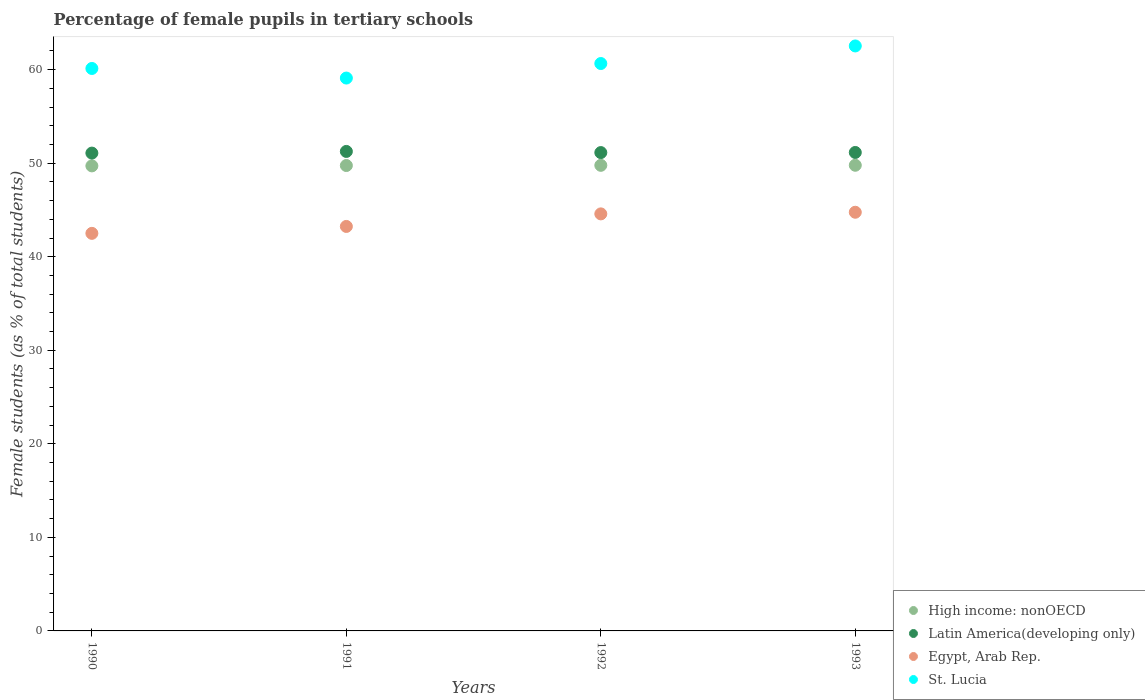What is the percentage of female pupils in tertiary schools in St. Lucia in 1992?
Ensure brevity in your answer.  60.65. Across all years, what is the maximum percentage of female pupils in tertiary schools in Latin America(developing only)?
Your answer should be very brief. 51.26. Across all years, what is the minimum percentage of female pupils in tertiary schools in St. Lucia?
Your answer should be very brief. 59.1. In which year was the percentage of female pupils in tertiary schools in St. Lucia maximum?
Your answer should be compact. 1993. What is the total percentage of female pupils in tertiary schools in Latin America(developing only) in the graph?
Offer a terse response. 204.62. What is the difference between the percentage of female pupils in tertiary schools in Latin America(developing only) in 1991 and that in 1992?
Provide a succinct answer. 0.12. What is the difference between the percentage of female pupils in tertiary schools in Egypt, Arab Rep. in 1992 and the percentage of female pupils in tertiary schools in St. Lucia in 1990?
Your response must be concise. -15.54. What is the average percentage of female pupils in tertiary schools in High income: nonOECD per year?
Offer a terse response. 49.75. In the year 1993, what is the difference between the percentage of female pupils in tertiary schools in Egypt, Arab Rep. and percentage of female pupils in tertiary schools in Latin America(developing only)?
Ensure brevity in your answer.  -6.39. What is the ratio of the percentage of female pupils in tertiary schools in High income: nonOECD in 1990 to that in 1993?
Your answer should be compact. 1. What is the difference between the highest and the second highest percentage of female pupils in tertiary schools in Latin America(developing only)?
Give a very brief answer. 0.11. What is the difference between the highest and the lowest percentage of female pupils in tertiary schools in Egypt, Arab Rep.?
Ensure brevity in your answer.  2.26. Is the sum of the percentage of female pupils in tertiary schools in Egypt, Arab Rep. in 1990 and 1993 greater than the maximum percentage of female pupils in tertiary schools in St. Lucia across all years?
Ensure brevity in your answer.  Yes. Is it the case that in every year, the sum of the percentage of female pupils in tertiary schools in Egypt, Arab Rep. and percentage of female pupils in tertiary schools in High income: nonOECD  is greater than the sum of percentage of female pupils in tertiary schools in St. Lucia and percentage of female pupils in tertiary schools in Latin America(developing only)?
Give a very brief answer. No. Does the percentage of female pupils in tertiary schools in Latin America(developing only) monotonically increase over the years?
Ensure brevity in your answer.  No. Is the percentage of female pupils in tertiary schools in High income: nonOECD strictly greater than the percentage of female pupils in tertiary schools in St. Lucia over the years?
Give a very brief answer. No. How many dotlines are there?
Offer a very short reply. 4. Does the graph contain grids?
Keep it short and to the point. No. How are the legend labels stacked?
Offer a terse response. Vertical. What is the title of the graph?
Offer a terse response. Percentage of female pupils in tertiary schools. What is the label or title of the X-axis?
Offer a terse response. Years. What is the label or title of the Y-axis?
Keep it short and to the point. Female students (as % of total students). What is the Female students (as % of total students) of High income: nonOECD in 1990?
Give a very brief answer. 49.71. What is the Female students (as % of total students) in Latin America(developing only) in 1990?
Provide a succinct answer. 51.08. What is the Female students (as % of total students) of Egypt, Arab Rep. in 1990?
Your answer should be very brief. 42.5. What is the Female students (as % of total students) in St. Lucia in 1990?
Your response must be concise. 60.13. What is the Female students (as % of total students) of High income: nonOECD in 1991?
Keep it short and to the point. 49.75. What is the Female students (as % of total students) in Latin America(developing only) in 1991?
Make the answer very short. 51.26. What is the Female students (as % of total students) in Egypt, Arab Rep. in 1991?
Offer a very short reply. 43.24. What is the Female students (as % of total students) of St. Lucia in 1991?
Make the answer very short. 59.1. What is the Female students (as % of total students) of High income: nonOECD in 1992?
Offer a terse response. 49.77. What is the Female students (as % of total students) of Latin America(developing only) in 1992?
Keep it short and to the point. 51.13. What is the Female students (as % of total students) in Egypt, Arab Rep. in 1992?
Your response must be concise. 44.58. What is the Female students (as % of total students) of St. Lucia in 1992?
Your answer should be compact. 60.65. What is the Female students (as % of total students) in High income: nonOECD in 1993?
Provide a succinct answer. 49.78. What is the Female students (as % of total students) in Latin America(developing only) in 1993?
Offer a terse response. 51.15. What is the Female students (as % of total students) of Egypt, Arab Rep. in 1993?
Make the answer very short. 44.76. What is the Female students (as % of total students) in St. Lucia in 1993?
Provide a succinct answer. 62.53. Across all years, what is the maximum Female students (as % of total students) of High income: nonOECD?
Your answer should be compact. 49.78. Across all years, what is the maximum Female students (as % of total students) of Latin America(developing only)?
Your answer should be very brief. 51.26. Across all years, what is the maximum Female students (as % of total students) of Egypt, Arab Rep.?
Provide a succinct answer. 44.76. Across all years, what is the maximum Female students (as % of total students) of St. Lucia?
Your answer should be very brief. 62.53. Across all years, what is the minimum Female students (as % of total students) of High income: nonOECD?
Ensure brevity in your answer.  49.71. Across all years, what is the minimum Female students (as % of total students) in Latin America(developing only)?
Make the answer very short. 51.08. Across all years, what is the minimum Female students (as % of total students) in Egypt, Arab Rep.?
Provide a short and direct response. 42.5. Across all years, what is the minimum Female students (as % of total students) of St. Lucia?
Your answer should be very brief. 59.1. What is the total Female students (as % of total students) of High income: nonOECD in the graph?
Provide a short and direct response. 199.01. What is the total Female students (as % of total students) of Latin America(developing only) in the graph?
Keep it short and to the point. 204.62. What is the total Female students (as % of total students) of Egypt, Arab Rep. in the graph?
Keep it short and to the point. 175.08. What is the total Female students (as % of total students) in St. Lucia in the graph?
Your response must be concise. 242.41. What is the difference between the Female students (as % of total students) in High income: nonOECD in 1990 and that in 1991?
Offer a terse response. -0.04. What is the difference between the Female students (as % of total students) in Latin America(developing only) in 1990 and that in 1991?
Provide a succinct answer. -0.18. What is the difference between the Female students (as % of total students) of Egypt, Arab Rep. in 1990 and that in 1991?
Provide a succinct answer. -0.74. What is the difference between the Female students (as % of total students) in St. Lucia in 1990 and that in 1991?
Your response must be concise. 1.02. What is the difference between the Female students (as % of total students) of High income: nonOECD in 1990 and that in 1992?
Keep it short and to the point. -0.06. What is the difference between the Female students (as % of total students) in Latin America(developing only) in 1990 and that in 1992?
Provide a succinct answer. -0.06. What is the difference between the Female students (as % of total students) in Egypt, Arab Rep. in 1990 and that in 1992?
Your answer should be very brief. -2.08. What is the difference between the Female students (as % of total students) in St. Lucia in 1990 and that in 1992?
Give a very brief answer. -0.53. What is the difference between the Female students (as % of total students) in High income: nonOECD in 1990 and that in 1993?
Ensure brevity in your answer.  -0.07. What is the difference between the Female students (as % of total students) of Latin America(developing only) in 1990 and that in 1993?
Offer a terse response. -0.07. What is the difference between the Female students (as % of total students) in Egypt, Arab Rep. in 1990 and that in 1993?
Your answer should be compact. -2.26. What is the difference between the Female students (as % of total students) in St. Lucia in 1990 and that in 1993?
Your response must be concise. -2.41. What is the difference between the Female students (as % of total students) in High income: nonOECD in 1991 and that in 1992?
Your answer should be very brief. -0.02. What is the difference between the Female students (as % of total students) in Latin America(developing only) in 1991 and that in 1992?
Make the answer very short. 0.12. What is the difference between the Female students (as % of total students) of Egypt, Arab Rep. in 1991 and that in 1992?
Your response must be concise. -1.34. What is the difference between the Female students (as % of total students) of St. Lucia in 1991 and that in 1992?
Offer a very short reply. -1.55. What is the difference between the Female students (as % of total students) of High income: nonOECD in 1991 and that in 1993?
Offer a very short reply. -0.03. What is the difference between the Female students (as % of total students) of Latin America(developing only) in 1991 and that in 1993?
Provide a succinct answer. 0.11. What is the difference between the Female students (as % of total students) of Egypt, Arab Rep. in 1991 and that in 1993?
Make the answer very short. -1.52. What is the difference between the Female students (as % of total students) of St. Lucia in 1991 and that in 1993?
Your answer should be very brief. -3.43. What is the difference between the Female students (as % of total students) of High income: nonOECD in 1992 and that in 1993?
Keep it short and to the point. -0.01. What is the difference between the Female students (as % of total students) of Latin America(developing only) in 1992 and that in 1993?
Give a very brief answer. -0.01. What is the difference between the Female students (as % of total students) in Egypt, Arab Rep. in 1992 and that in 1993?
Offer a very short reply. -0.17. What is the difference between the Female students (as % of total students) of St. Lucia in 1992 and that in 1993?
Ensure brevity in your answer.  -1.88. What is the difference between the Female students (as % of total students) in High income: nonOECD in 1990 and the Female students (as % of total students) in Latin America(developing only) in 1991?
Make the answer very short. -1.55. What is the difference between the Female students (as % of total students) of High income: nonOECD in 1990 and the Female students (as % of total students) of Egypt, Arab Rep. in 1991?
Provide a succinct answer. 6.47. What is the difference between the Female students (as % of total students) in High income: nonOECD in 1990 and the Female students (as % of total students) in St. Lucia in 1991?
Give a very brief answer. -9.39. What is the difference between the Female students (as % of total students) in Latin America(developing only) in 1990 and the Female students (as % of total students) in Egypt, Arab Rep. in 1991?
Provide a succinct answer. 7.84. What is the difference between the Female students (as % of total students) in Latin America(developing only) in 1990 and the Female students (as % of total students) in St. Lucia in 1991?
Provide a succinct answer. -8.02. What is the difference between the Female students (as % of total students) of Egypt, Arab Rep. in 1990 and the Female students (as % of total students) of St. Lucia in 1991?
Make the answer very short. -16.6. What is the difference between the Female students (as % of total students) of High income: nonOECD in 1990 and the Female students (as % of total students) of Latin America(developing only) in 1992?
Make the answer very short. -1.42. What is the difference between the Female students (as % of total students) of High income: nonOECD in 1990 and the Female students (as % of total students) of Egypt, Arab Rep. in 1992?
Your answer should be very brief. 5.13. What is the difference between the Female students (as % of total students) of High income: nonOECD in 1990 and the Female students (as % of total students) of St. Lucia in 1992?
Provide a succinct answer. -10.94. What is the difference between the Female students (as % of total students) of Latin America(developing only) in 1990 and the Female students (as % of total students) of Egypt, Arab Rep. in 1992?
Make the answer very short. 6.5. What is the difference between the Female students (as % of total students) of Latin America(developing only) in 1990 and the Female students (as % of total students) of St. Lucia in 1992?
Offer a very short reply. -9.57. What is the difference between the Female students (as % of total students) in Egypt, Arab Rep. in 1990 and the Female students (as % of total students) in St. Lucia in 1992?
Give a very brief answer. -18.15. What is the difference between the Female students (as % of total students) of High income: nonOECD in 1990 and the Female students (as % of total students) of Latin America(developing only) in 1993?
Your response must be concise. -1.43. What is the difference between the Female students (as % of total students) of High income: nonOECD in 1990 and the Female students (as % of total students) of Egypt, Arab Rep. in 1993?
Keep it short and to the point. 4.96. What is the difference between the Female students (as % of total students) in High income: nonOECD in 1990 and the Female students (as % of total students) in St. Lucia in 1993?
Offer a terse response. -12.82. What is the difference between the Female students (as % of total students) in Latin America(developing only) in 1990 and the Female students (as % of total students) in Egypt, Arab Rep. in 1993?
Provide a succinct answer. 6.32. What is the difference between the Female students (as % of total students) of Latin America(developing only) in 1990 and the Female students (as % of total students) of St. Lucia in 1993?
Provide a succinct answer. -11.45. What is the difference between the Female students (as % of total students) of Egypt, Arab Rep. in 1990 and the Female students (as % of total students) of St. Lucia in 1993?
Your answer should be very brief. -20.03. What is the difference between the Female students (as % of total students) of High income: nonOECD in 1991 and the Female students (as % of total students) of Latin America(developing only) in 1992?
Keep it short and to the point. -1.38. What is the difference between the Female students (as % of total students) in High income: nonOECD in 1991 and the Female students (as % of total students) in Egypt, Arab Rep. in 1992?
Your answer should be very brief. 5.17. What is the difference between the Female students (as % of total students) of High income: nonOECD in 1991 and the Female students (as % of total students) of St. Lucia in 1992?
Make the answer very short. -10.9. What is the difference between the Female students (as % of total students) of Latin America(developing only) in 1991 and the Female students (as % of total students) of Egypt, Arab Rep. in 1992?
Provide a succinct answer. 6.68. What is the difference between the Female students (as % of total students) of Latin America(developing only) in 1991 and the Female students (as % of total students) of St. Lucia in 1992?
Offer a very short reply. -9.4. What is the difference between the Female students (as % of total students) in Egypt, Arab Rep. in 1991 and the Female students (as % of total students) in St. Lucia in 1992?
Give a very brief answer. -17.41. What is the difference between the Female students (as % of total students) in High income: nonOECD in 1991 and the Female students (as % of total students) in Latin America(developing only) in 1993?
Offer a very short reply. -1.4. What is the difference between the Female students (as % of total students) of High income: nonOECD in 1991 and the Female students (as % of total students) of Egypt, Arab Rep. in 1993?
Your answer should be very brief. 5. What is the difference between the Female students (as % of total students) of High income: nonOECD in 1991 and the Female students (as % of total students) of St. Lucia in 1993?
Offer a very short reply. -12.78. What is the difference between the Female students (as % of total students) in Latin America(developing only) in 1991 and the Female students (as % of total students) in Egypt, Arab Rep. in 1993?
Make the answer very short. 6.5. What is the difference between the Female students (as % of total students) in Latin America(developing only) in 1991 and the Female students (as % of total students) in St. Lucia in 1993?
Offer a very short reply. -11.28. What is the difference between the Female students (as % of total students) of Egypt, Arab Rep. in 1991 and the Female students (as % of total students) of St. Lucia in 1993?
Ensure brevity in your answer.  -19.29. What is the difference between the Female students (as % of total students) of High income: nonOECD in 1992 and the Female students (as % of total students) of Latin America(developing only) in 1993?
Keep it short and to the point. -1.37. What is the difference between the Female students (as % of total students) in High income: nonOECD in 1992 and the Female students (as % of total students) in Egypt, Arab Rep. in 1993?
Your answer should be very brief. 5.02. What is the difference between the Female students (as % of total students) in High income: nonOECD in 1992 and the Female students (as % of total students) in St. Lucia in 1993?
Keep it short and to the point. -12.76. What is the difference between the Female students (as % of total students) in Latin America(developing only) in 1992 and the Female students (as % of total students) in Egypt, Arab Rep. in 1993?
Offer a terse response. 6.38. What is the difference between the Female students (as % of total students) in Latin America(developing only) in 1992 and the Female students (as % of total students) in St. Lucia in 1993?
Provide a short and direct response. -11.4. What is the difference between the Female students (as % of total students) of Egypt, Arab Rep. in 1992 and the Female students (as % of total students) of St. Lucia in 1993?
Make the answer very short. -17.95. What is the average Female students (as % of total students) in High income: nonOECD per year?
Your answer should be very brief. 49.75. What is the average Female students (as % of total students) of Latin America(developing only) per year?
Your answer should be very brief. 51.15. What is the average Female students (as % of total students) of Egypt, Arab Rep. per year?
Provide a short and direct response. 43.77. What is the average Female students (as % of total students) in St. Lucia per year?
Your answer should be compact. 60.6. In the year 1990, what is the difference between the Female students (as % of total students) of High income: nonOECD and Female students (as % of total students) of Latin America(developing only)?
Offer a very short reply. -1.37. In the year 1990, what is the difference between the Female students (as % of total students) in High income: nonOECD and Female students (as % of total students) in Egypt, Arab Rep.?
Your response must be concise. 7.21. In the year 1990, what is the difference between the Female students (as % of total students) of High income: nonOECD and Female students (as % of total students) of St. Lucia?
Make the answer very short. -10.41. In the year 1990, what is the difference between the Female students (as % of total students) in Latin America(developing only) and Female students (as % of total students) in Egypt, Arab Rep.?
Keep it short and to the point. 8.58. In the year 1990, what is the difference between the Female students (as % of total students) of Latin America(developing only) and Female students (as % of total students) of St. Lucia?
Your answer should be very brief. -9.05. In the year 1990, what is the difference between the Female students (as % of total students) in Egypt, Arab Rep. and Female students (as % of total students) in St. Lucia?
Ensure brevity in your answer.  -17.63. In the year 1991, what is the difference between the Female students (as % of total students) in High income: nonOECD and Female students (as % of total students) in Latin America(developing only)?
Make the answer very short. -1.51. In the year 1991, what is the difference between the Female students (as % of total students) of High income: nonOECD and Female students (as % of total students) of Egypt, Arab Rep.?
Ensure brevity in your answer.  6.51. In the year 1991, what is the difference between the Female students (as % of total students) in High income: nonOECD and Female students (as % of total students) in St. Lucia?
Provide a succinct answer. -9.35. In the year 1991, what is the difference between the Female students (as % of total students) in Latin America(developing only) and Female students (as % of total students) in Egypt, Arab Rep.?
Your response must be concise. 8.02. In the year 1991, what is the difference between the Female students (as % of total students) of Latin America(developing only) and Female students (as % of total students) of St. Lucia?
Ensure brevity in your answer.  -7.84. In the year 1991, what is the difference between the Female students (as % of total students) of Egypt, Arab Rep. and Female students (as % of total students) of St. Lucia?
Ensure brevity in your answer.  -15.86. In the year 1992, what is the difference between the Female students (as % of total students) of High income: nonOECD and Female students (as % of total students) of Latin America(developing only)?
Your answer should be very brief. -1.36. In the year 1992, what is the difference between the Female students (as % of total students) in High income: nonOECD and Female students (as % of total students) in Egypt, Arab Rep.?
Make the answer very short. 5.19. In the year 1992, what is the difference between the Female students (as % of total students) of High income: nonOECD and Female students (as % of total students) of St. Lucia?
Your answer should be very brief. -10.88. In the year 1992, what is the difference between the Female students (as % of total students) in Latin America(developing only) and Female students (as % of total students) in Egypt, Arab Rep.?
Your response must be concise. 6.55. In the year 1992, what is the difference between the Female students (as % of total students) of Latin America(developing only) and Female students (as % of total students) of St. Lucia?
Ensure brevity in your answer.  -9.52. In the year 1992, what is the difference between the Female students (as % of total students) in Egypt, Arab Rep. and Female students (as % of total students) in St. Lucia?
Your answer should be compact. -16.07. In the year 1993, what is the difference between the Female students (as % of total students) in High income: nonOECD and Female students (as % of total students) in Latin America(developing only)?
Offer a terse response. -1.37. In the year 1993, what is the difference between the Female students (as % of total students) of High income: nonOECD and Female students (as % of total students) of Egypt, Arab Rep.?
Offer a very short reply. 5.02. In the year 1993, what is the difference between the Female students (as % of total students) of High income: nonOECD and Female students (as % of total students) of St. Lucia?
Keep it short and to the point. -12.75. In the year 1993, what is the difference between the Female students (as % of total students) of Latin America(developing only) and Female students (as % of total students) of Egypt, Arab Rep.?
Your response must be concise. 6.39. In the year 1993, what is the difference between the Female students (as % of total students) of Latin America(developing only) and Female students (as % of total students) of St. Lucia?
Offer a very short reply. -11.39. In the year 1993, what is the difference between the Female students (as % of total students) of Egypt, Arab Rep. and Female students (as % of total students) of St. Lucia?
Ensure brevity in your answer.  -17.78. What is the ratio of the Female students (as % of total students) of High income: nonOECD in 1990 to that in 1991?
Make the answer very short. 1. What is the ratio of the Female students (as % of total students) in Latin America(developing only) in 1990 to that in 1991?
Offer a very short reply. 1. What is the ratio of the Female students (as % of total students) of Egypt, Arab Rep. in 1990 to that in 1991?
Your answer should be compact. 0.98. What is the ratio of the Female students (as % of total students) of St. Lucia in 1990 to that in 1991?
Provide a short and direct response. 1.02. What is the ratio of the Female students (as % of total students) in High income: nonOECD in 1990 to that in 1992?
Your response must be concise. 1. What is the ratio of the Female students (as % of total students) of Egypt, Arab Rep. in 1990 to that in 1992?
Provide a succinct answer. 0.95. What is the ratio of the Female students (as % of total students) in High income: nonOECD in 1990 to that in 1993?
Provide a succinct answer. 1. What is the ratio of the Female students (as % of total students) of Latin America(developing only) in 1990 to that in 1993?
Ensure brevity in your answer.  1. What is the ratio of the Female students (as % of total students) in Egypt, Arab Rep. in 1990 to that in 1993?
Keep it short and to the point. 0.95. What is the ratio of the Female students (as % of total students) of St. Lucia in 1990 to that in 1993?
Give a very brief answer. 0.96. What is the ratio of the Female students (as % of total students) of Latin America(developing only) in 1991 to that in 1992?
Offer a very short reply. 1. What is the ratio of the Female students (as % of total students) of Egypt, Arab Rep. in 1991 to that in 1992?
Your response must be concise. 0.97. What is the ratio of the Female students (as % of total students) in St. Lucia in 1991 to that in 1992?
Your answer should be very brief. 0.97. What is the ratio of the Female students (as % of total students) of High income: nonOECD in 1991 to that in 1993?
Make the answer very short. 1. What is the ratio of the Female students (as % of total students) in Latin America(developing only) in 1991 to that in 1993?
Keep it short and to the point. 1. What is the ratio of the Female students (as % of total students) in Egypt, Arab Rep. in 1991 to that in 1993?
Offer a very short reply. 0.97. What is the ratio of the Female students (as % of total students) of St. Lucia in 1991 to that in 1993?
Provide a short and direct response. 0.95. What is the ratio of the Female students (as % of total students) in St. Lucia in 1992 to that in 1993?
Give a very brief answer. 0.97. What is the difference between the highest and the second highest Female students (as % of total students) of High income: nonOECD?
Provide a succinct answer. 0.01. What is the difference between the highest and the second highest Female students (as % of total students) in Latin America(developing only)?
Make the answer very short. 0.11. What is the difference between the highest and the second highest Female students (as % of total students) of Egypt, Arab Rep.?
Your response must be concise. 0.17. What is the difference between the highest and the second highest Female students (as % of total students) of St. Lucia?
Make the answer very short. 1.88. What is the difference between the highest and the lowest Female students (as % of total students) in High income: nonOECD?
Your answer should be very brief. 0.07. What is the difference between the highest and the lowest Female students (as % of total students) of Latin America(developing only)?
Provide a succinct answer. 0.18. What is the difference between the highest and the lowest Female students (as % of total students) of Egypt, Arab Rep.?
Provide a short and direct response. 2.26. What is the difference between the highest and the lowest Female students (as % of total students) of St. Lucia?
Your answer should be very brief. 3.43. 